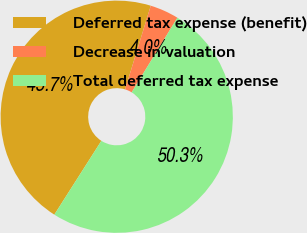Convert chart. <chart><loc_0><loc_0><loc_500><loc_500><pie_chart><fcel>Deferred tax expense (benefit)<fcel>Decrease in valuation<fcel>Total deferred tax expense<nl><fcel>45.71%<fcel>4.02%<fcel>50.28%<nl></chart> 